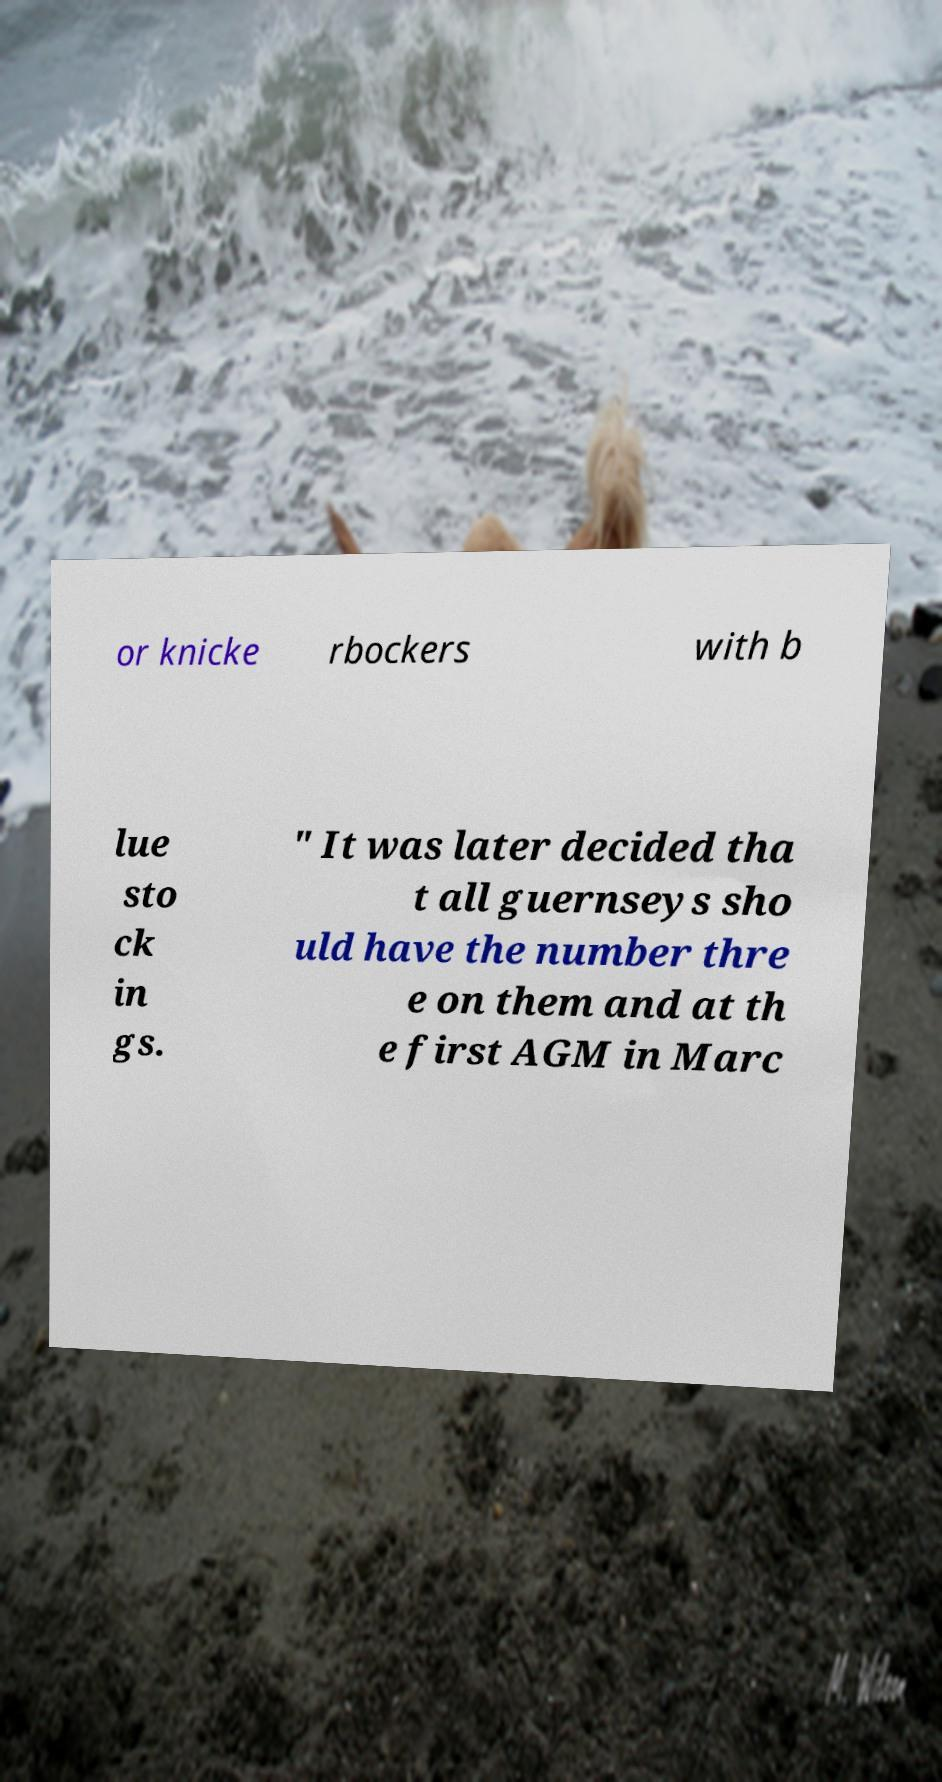Can you read and provide the text displayed in the image?This photo seems to have some interesting text. Can you extract and type it out for me? or knicke rbockers with b lue sto ck in gs. " It was later decided tha t all guernseys sho uld have the number thre e on them and at th e first AGM in Marc 